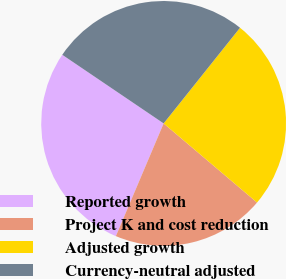Convert chart. <chart><loc_0><loc_0><loc_500><loc_500><pie_chart><fcel>Reported growth<fcel>Project K and cost reduction<fcel>Adjusted growth<fcel>Currency-neutral adjusted<nl><fcel>28.09%<fcel>20.19%<fcel>25.46%<fcel>26.25%<nl></chart> 